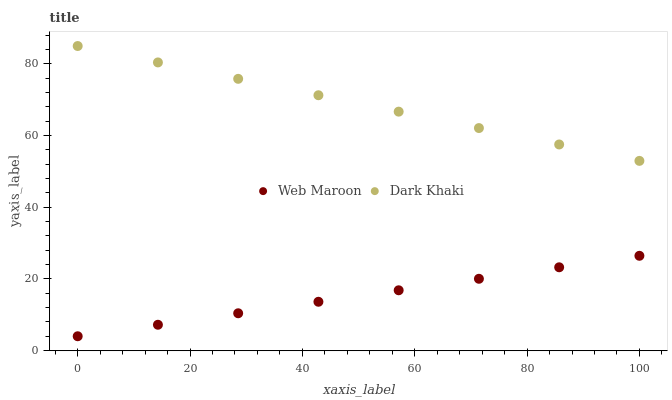Does Web Maroon have the minimum area under the curve?
Answer yes or no. Yes. Does Dark Khaki have the maximum area under the curve?
Answer yes or no. Yes. Does Web Maroon have the maximum area under the curve?
Answer yes or no. No. Is Web Maroon the smoothest?
Answer yes or no. Yes. Is Dark Khaki the roughest?
Answer yes or no. Yes. Is Web Maroon the roughest?
Answer yes or no. No. Does Web Maroon have the lowest value?
Answer yes or no. Yes. Does Dark Khaki have the highest value?
Answer yes or no. Yes. Does Web Maroon have the highest value?
Answer yes or no. No. Is Web Maroon less than Dark Khaki?
Answer yes or no. Yes. Is Dark Khaki greater than Web Maroon?
Answer yes or no. Yes. Does Web Maroon intersect Dark Khaki?
Answer yes or no. No. 